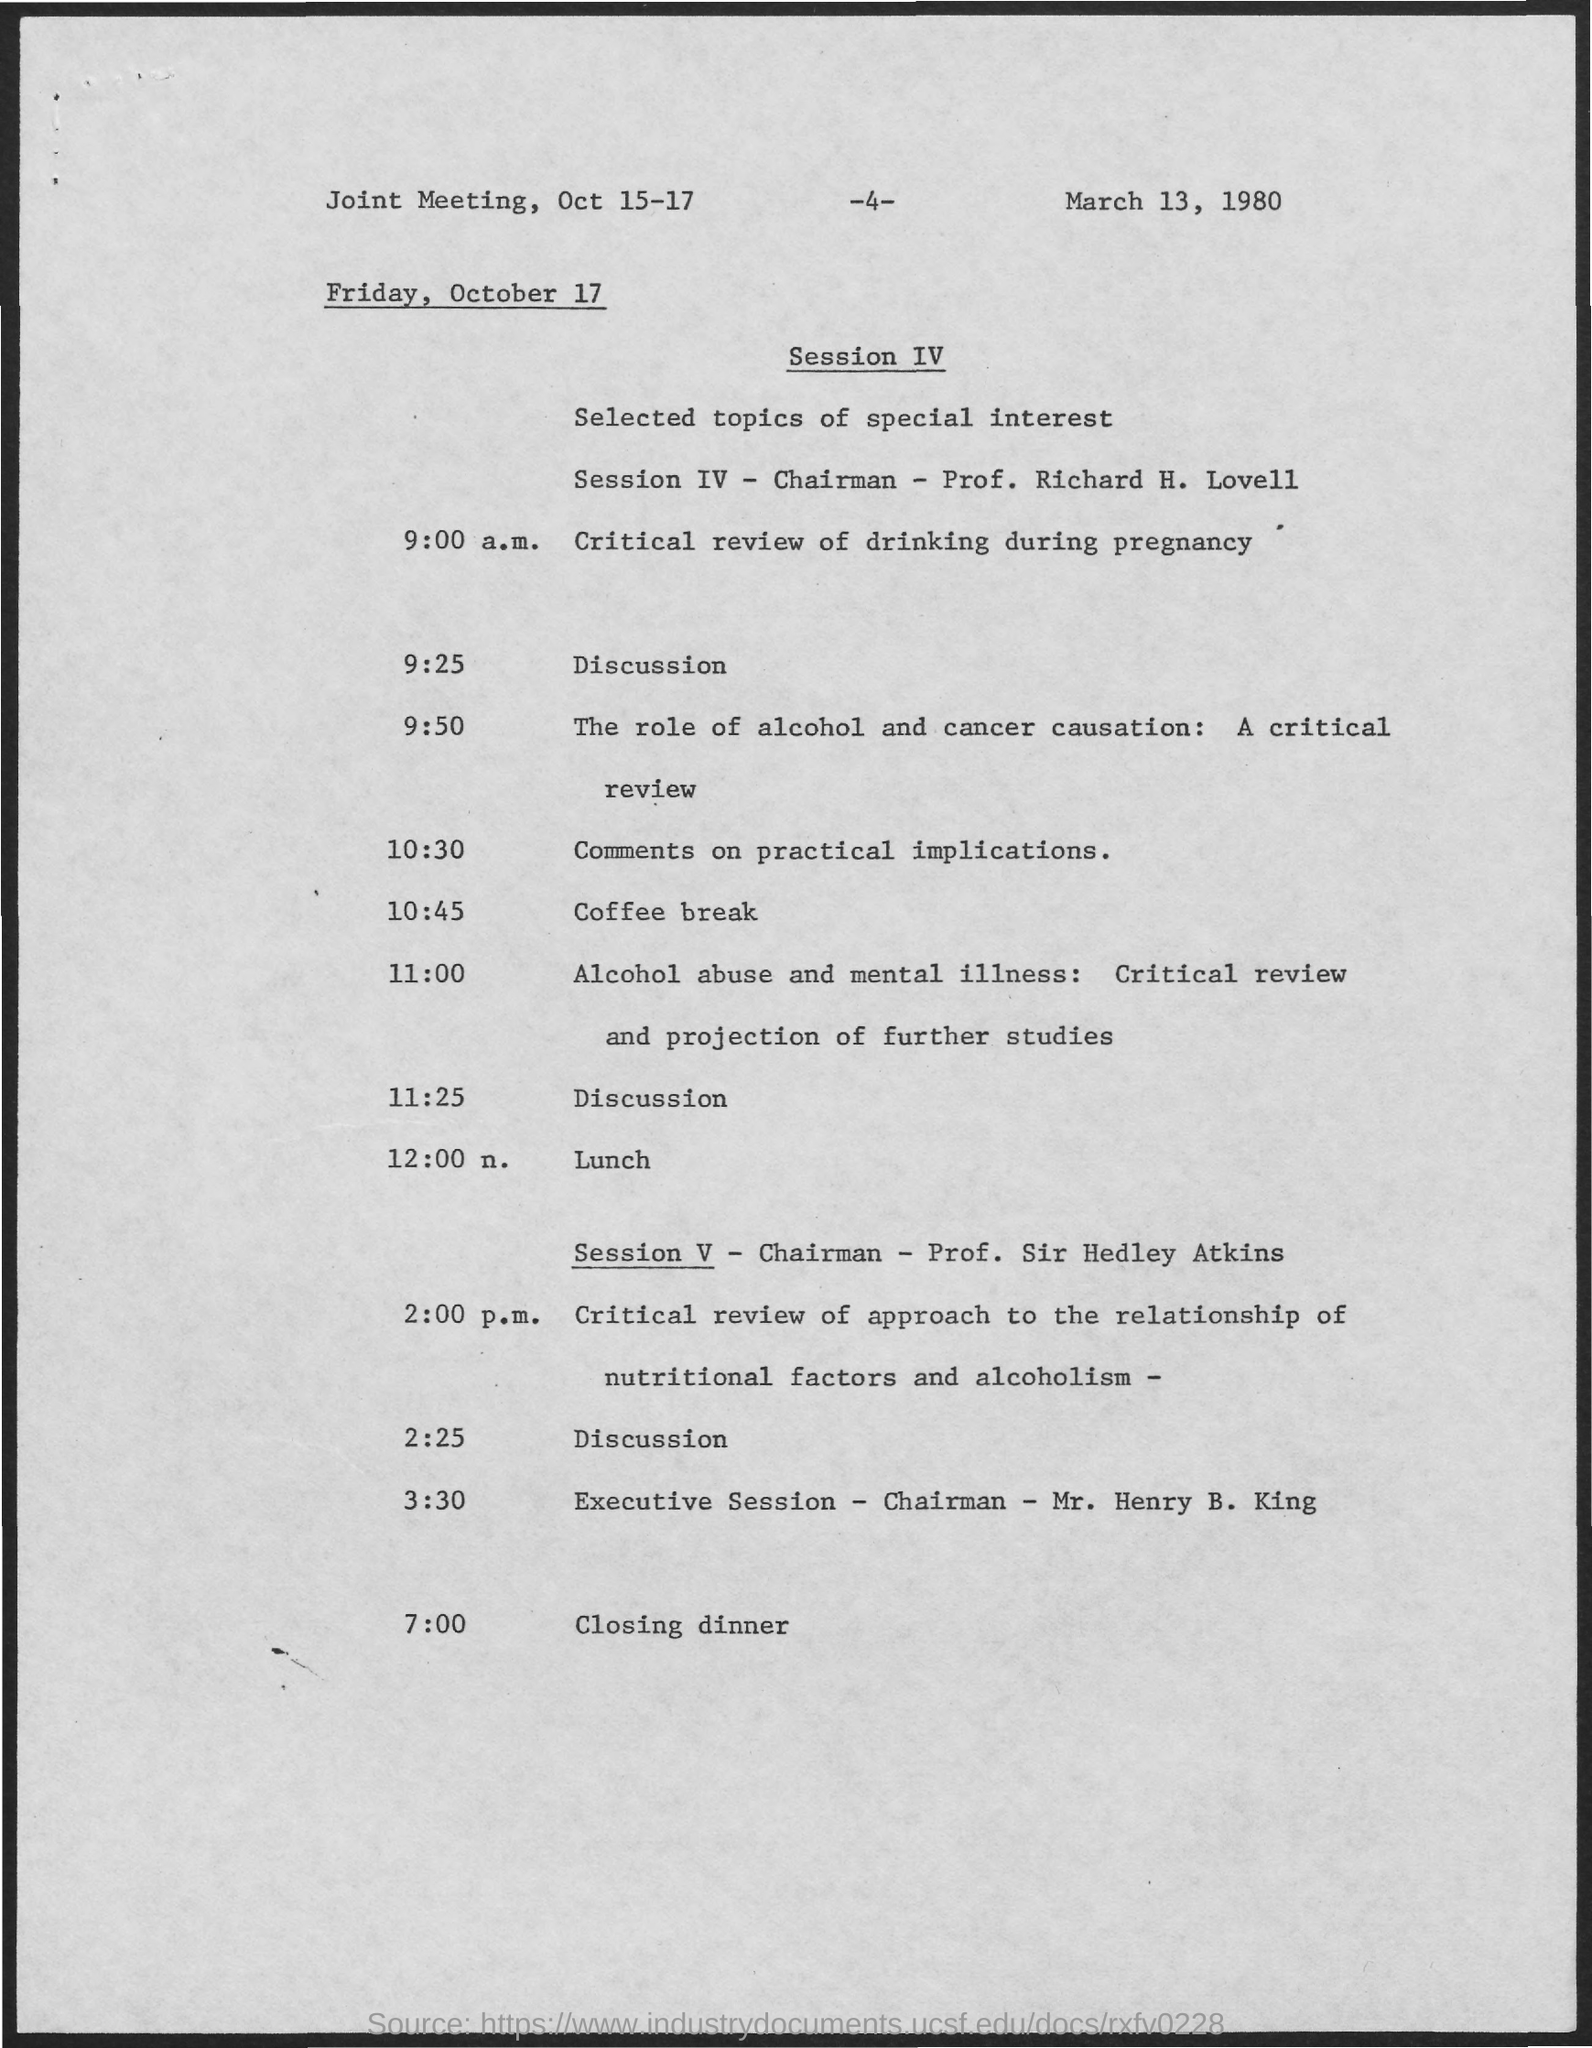Who is the chairman for session iv ?
Offer a very short reply. Prof. Richard H. Lovell. What is the page number at top of the page?
Provide a succinct answer. 4. Who is the chairman for session v?
Offer a terse response. Prof. Sir Hedley Atkins. Who is the chairman for executive session?
Make the answer very short. Mr. Henry B. King. What is the time scheduled for lunch?
Provide a succinct answer. 12:00 n. What is the time scheduled for closing dinner?
Provide a succinct answer. 7:00. What is the time scheduled for coffee break?
Provide a succinct answer. 10:45. 